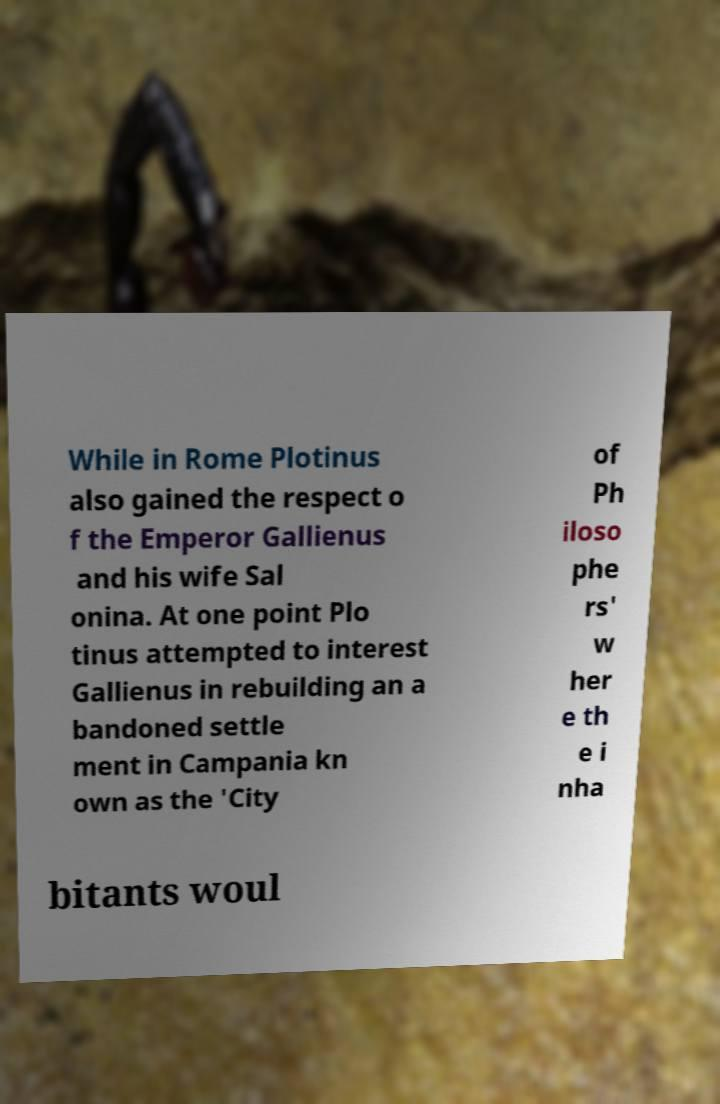Please identify and transcribe the text found in this image. While in Rome Plotinus also gained the respect o f the Emperor Gallienus and his wife Sal onina. At one point Plo tinus attempted to interest Gallienus in rebuilding an a bandoned settle ment in Campania kn own as the 'City of Ph iloso phe rs' w her e th e i nha bitants woul 